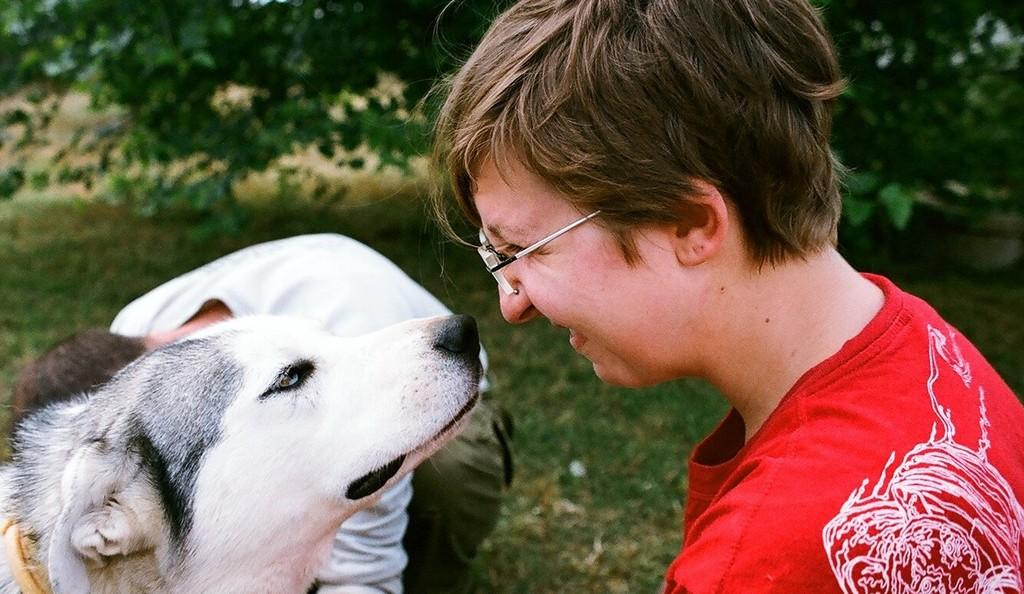How many people are in the image? There are a few people in the image. What type of animal is present in the image? There is an animal in the image. What is the ground covered with in the image? The ground is covered with grass. How many trees can be seen in the image? There are a few trees in the image. What country is the beggar from in the image? There is no beggar present in the image, so it is not possible to determine the country of origin. 